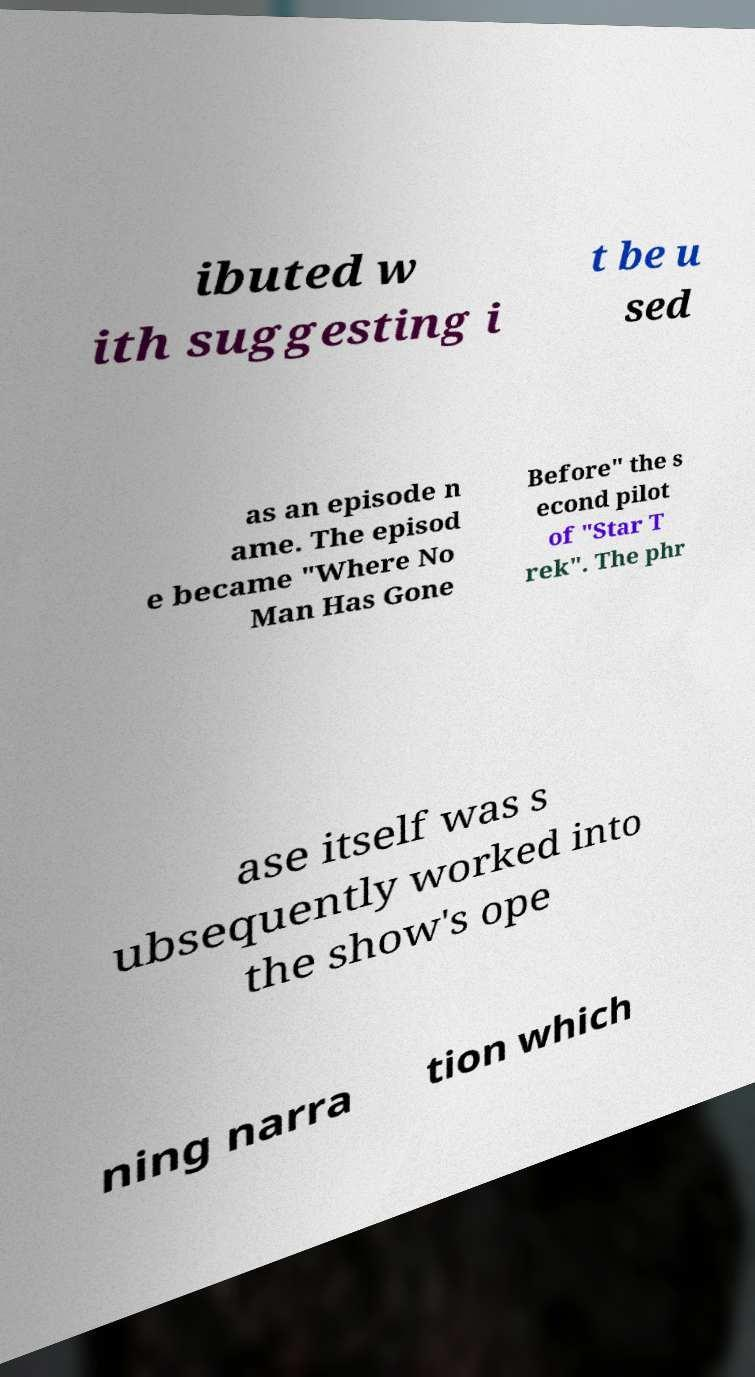Could you assist in decoding the text presented in this image and type it out clearly? ibuted w ith suggesting i t be u sed as an episode n ame. The episod e became "Where No Man Has Gone Before" the s econd pilot of "Star T rek". The phr ase itself was s ubsequently worked into the show's ope ning narra tion which 